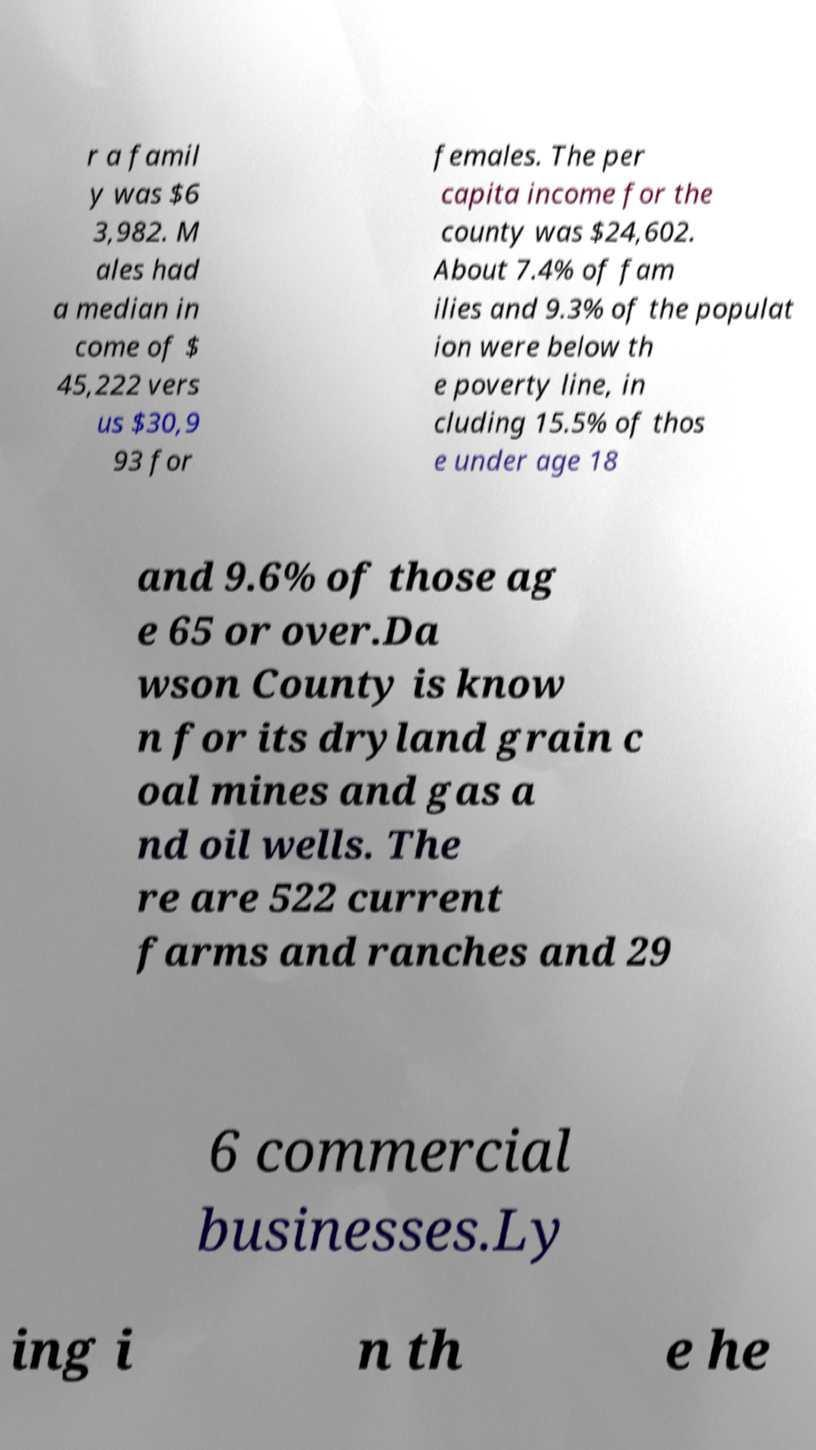For documentation purposes, I need the text within this image transcribed. Could you provide that? r a famil y was $6 3,982. M ales had a median in come of $ 45,222 vers us $30,9 93 for females. The per capita income for the county was $24,602. About 7.4% of fam ilies and 9.3% of the populat ion were below th e poverty line, in cluding 15.5% of thos e under age 18 and 9.6% of those ag e 65 or over.Da wson County is know n for its dryland grain c oal mines and gas a nd oil wells. The re are 522 current farms and ranches and 29 6 commercial businesses.Ly ing i n th e he 